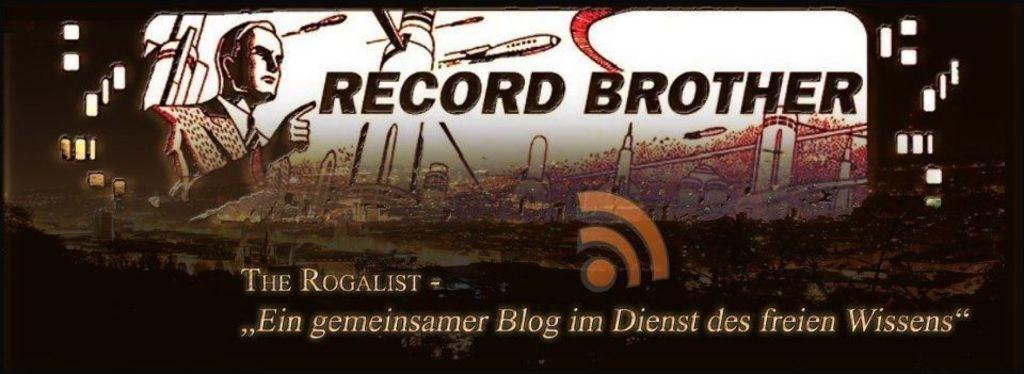<image>
Present a compact description of the photo's key features. A person pointing a finger next to the text RECORD BROTHER. 